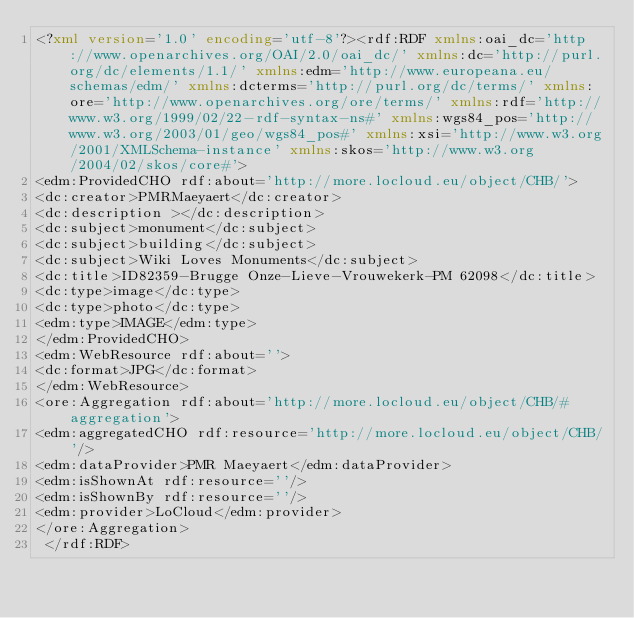Convert code to text. <code><loc_0><loc_0><loc_500><loc_500><_XML_><?xml version='1.0' encoding='utf-8'?><rdf:RDF xmlns:oai_dc='http://www.openarchives.org/OAI/2.0/oai_dc/' xmlns:dc='http://purl.org/dc/elements/1.1/' xmlns:edm='http://www.europeana.eu/schemas/edm/' xmlns:dcterms='http://purl.org/dc/terms/' xmlns:ore='http://www.openarchives.org/ore/terms/' xmlns:rdf='http://www.w3.org/1999/02/22-rdf-syntax-ns#' xmlns:wgs84_pos='http://www.w3.org/2003/01/geo/wgs84_pos#' xmlns:xsi='http://www.w3.org/2001/XMLSchema-instance' xmlns:skos='http://www.w3.org/2004/02/skos/core#'>
<edm:ProvidedCHO rdf:about='http://more.locloud.eu/object/CHB/'>
<dc:creator>PMRMaeyaert</dc:creator>
<dc:description ></dc:description>
<dc:subject>monument</dc:subject>
<dc:subject>building</dc:subject>
<dc:subject>Wiki Loves Monuments</dc:subject>
<dc:title>ID82359-Brugge Onze-Lieve-Vrouwekerk-PM 62098</dc:title>
<dc:type>image</dc:type>
<dc:type>photo</dc:type>
<edm:type>IMAGE</edm:type>
</edm:ProvidedCHO>
<edm:WebResource rdf:about=''>
<dc:format>JPG</dc:format>
</edm:WebResource>
<ore:Aggregation rdf:about='http://more.locloud.eu/object/CHB/#aggregation'>
<edm:aggregatedCHO rdf:resource='http://more.locloud.eu/object/CHB/'/>
<edm:dataProvider>PMR Maeyaert</edm:dataProvider>
<edm:isShownAt rdf:resource=''/>
<edm:isShownBy rdf:resource=''/>
<edm:provider>LoCloud</edm:provider>
</ore:Aggregation>
 </rdf:RDF>
</code> 